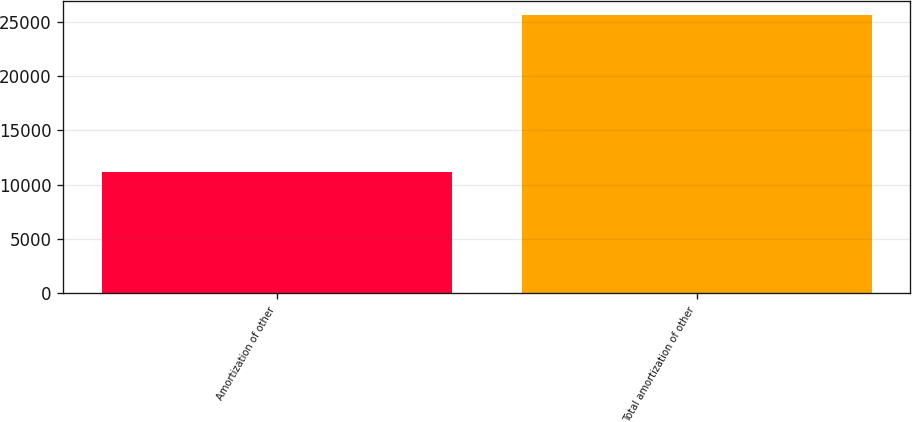Convert chart to OTSL. <chart><loc_0><loc_0><loc_500><loc_500><bar_chart><fcel>Amortization of other<fcel>Total amortization of other<nl><fcel>11155<fcel>25663<nl></chart> 